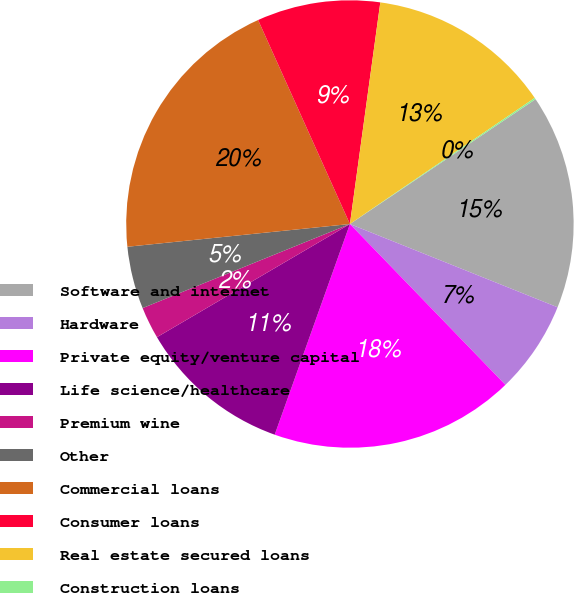Convert chart to OTSL. <chart><loc_0><loc_0><loc_500><loc_500><pie_chart><fcel>Software and internet<fcel>Hardware<fcel>Private equity/venture capital<fcel>Life science/healthcare<fcel>Premium wine<fcel>Other<fcel>Commercial loans<fcel>Consumer loans<fcel>Real estate secured loans<fcel>Construction loans<nl><fcel>15.49%<fcel>6.7%<fcel>17.69%<fcel>11.1%<fcel>2.31%<fcel>4.51%<fcel>19.89%<fcel>8.9%<fcel>13.3%<fcel>0.11%<nl></chart> 